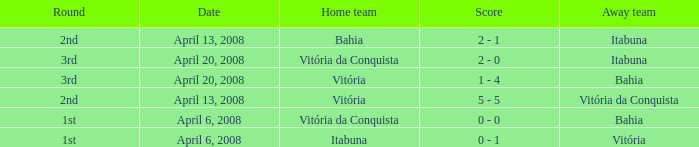Who was the home team on April 13, 2008 when Itabuna was the away team? Bahia. 